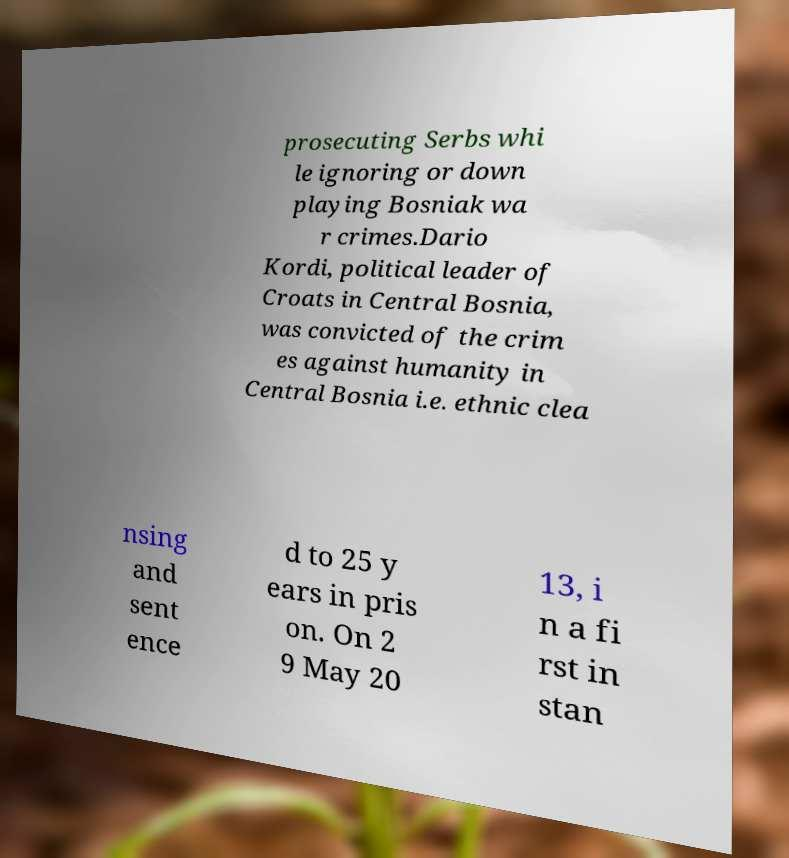There's text embedded in this image that I need extracted. Can you transcribe it verbatim? prosecuting Serbs whi le ignoring or down playing Bosniak wa r crimes.Dario Kordi, political leader of Croats in Central Bosnia, was convicted of the crim es against humanity in Central Bosnia i.e. ethnic clea nsing and sent ence d to 25 y ears in pris on. On 2 9 May 20 13, i n a fi rst in stan 